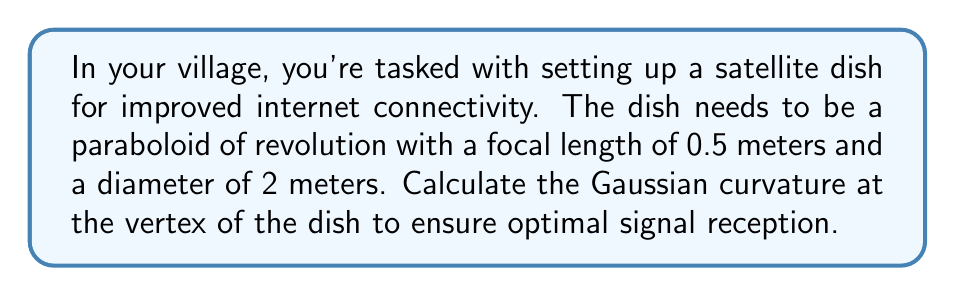Teach me how to tackle this problem. Let's approach this step-by-step:

1) A paraboloid of revolution is formed by rotating a parabola around its axis of symmetry. The general equation of a parabola with vertex at the origin is:

   $$y = \frac{1}{4f}x^2$$

   where $f$ is the focal length.

2) In our case, $f = 0.5$ meters. So the equation of our parabola is:

   $$y = \frac{1}{2}x^2$$

3) To find the Gaussian curvature, we need to use the formula for a surface of revolution:

   $$K = \frac{f''(x)}{(1 + [f'(x)]^2)^2}$$

   where $f(x)$ is our function $\frac{1}{2}x^2$.

4) Let's calculate $f'(x)$ and $f''(x)$:
   
   $$f'(x) = x$$
   $$f''(x) = 1$$

5) At the vertex, $x = 0$. Substituting into our curvature formula:

   $$K = \frac{1}{(1 + [0]^2)^2} = 1$$

6) Therefore, the Gaussian curvature at the vertex of the dish is 1 m^(-2).

[asy]
import graph;
size(200,200);
real f(real x) {return 0.5*x^2;}
draw(graph(f,-2,2));
draw((-2,0)--(2,0),arrow=Arrow);
draw((0,0)--(0,2),arrow=Arrow);
label("x",(-2,0),SW);
label("y",(0,2),NW);
label("y = 0.5x^2",(1.5,f(1.5)),E);
[/asy]
Answer: 1 m^(-2) 